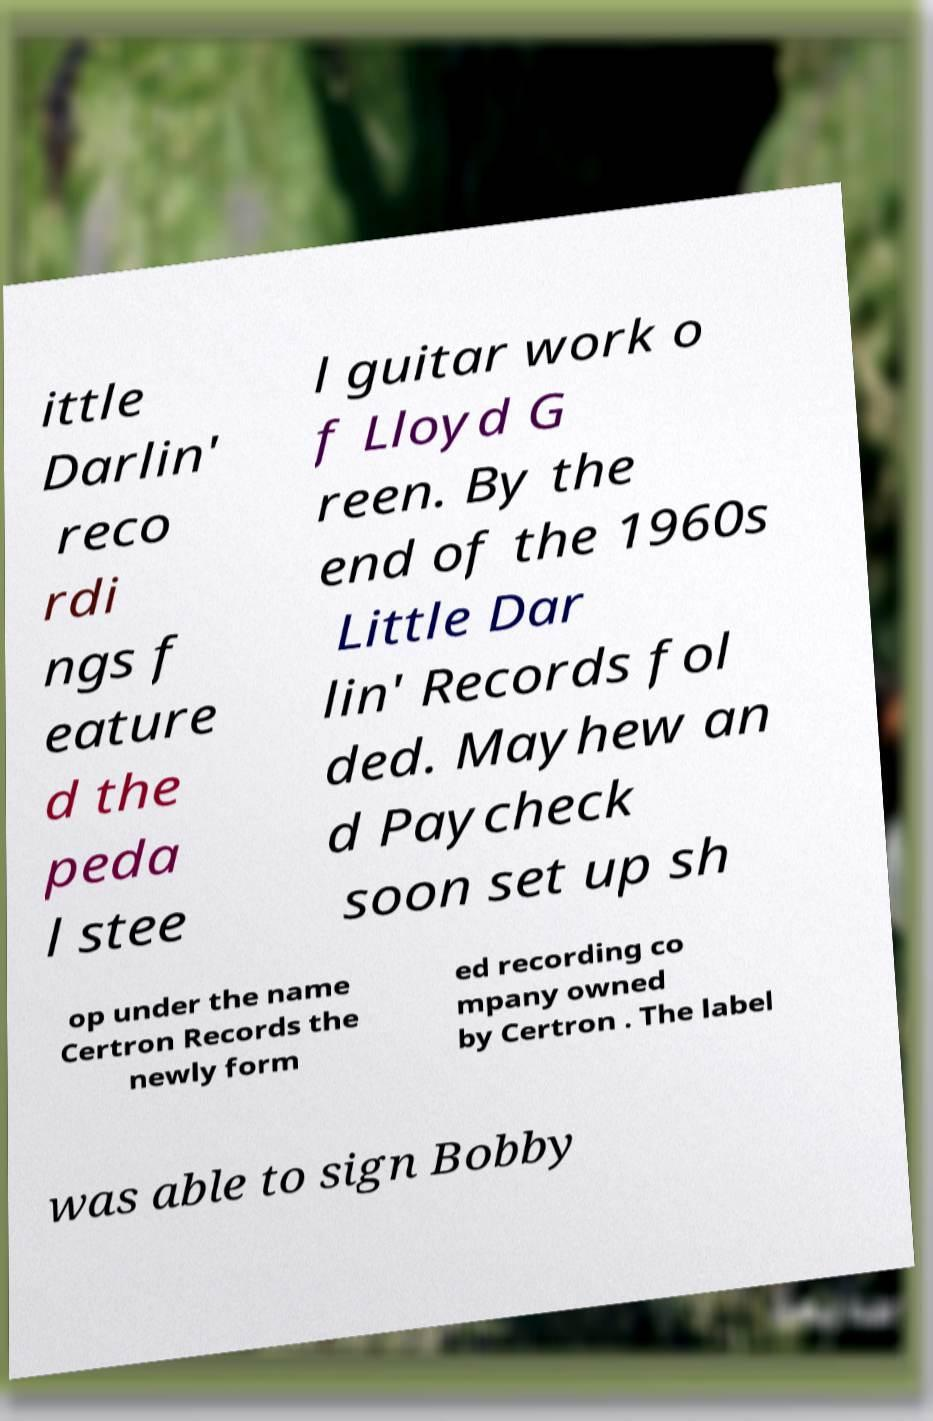For documentation purposes, I need the text within this image transcribed. Could you provide that? ittle Darlin' reco rdi ngs f eature d the peda l stee l guitar work o f Lloyd G reen. By the end of the 1960s Little Dar lin' Records fol ded. Mayhew an d Paycheck soon set up sh op under the name Certron Records the newly form ed recording co mpany owned by Certron . The label was able to sign Bobby 